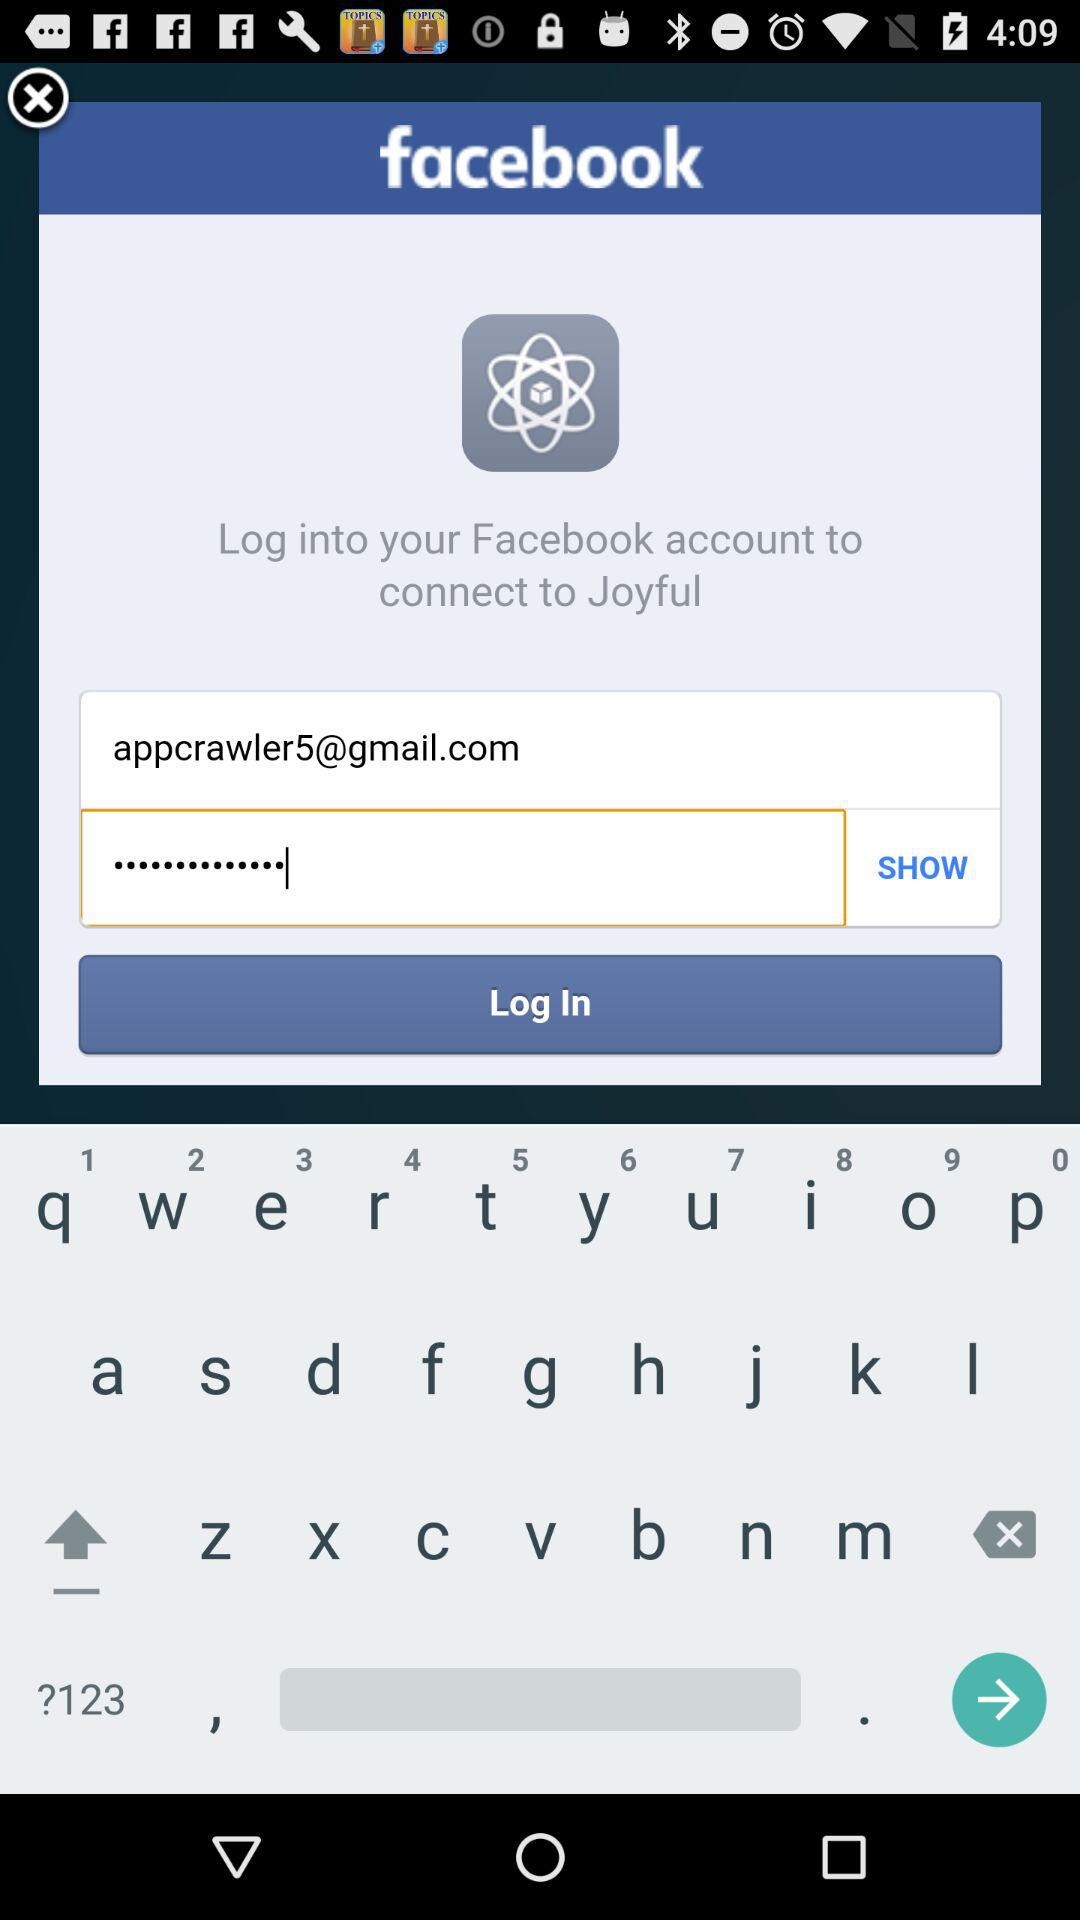How many text inputs are there that are not empty?
Answer the question using a single word or phrase. 2 